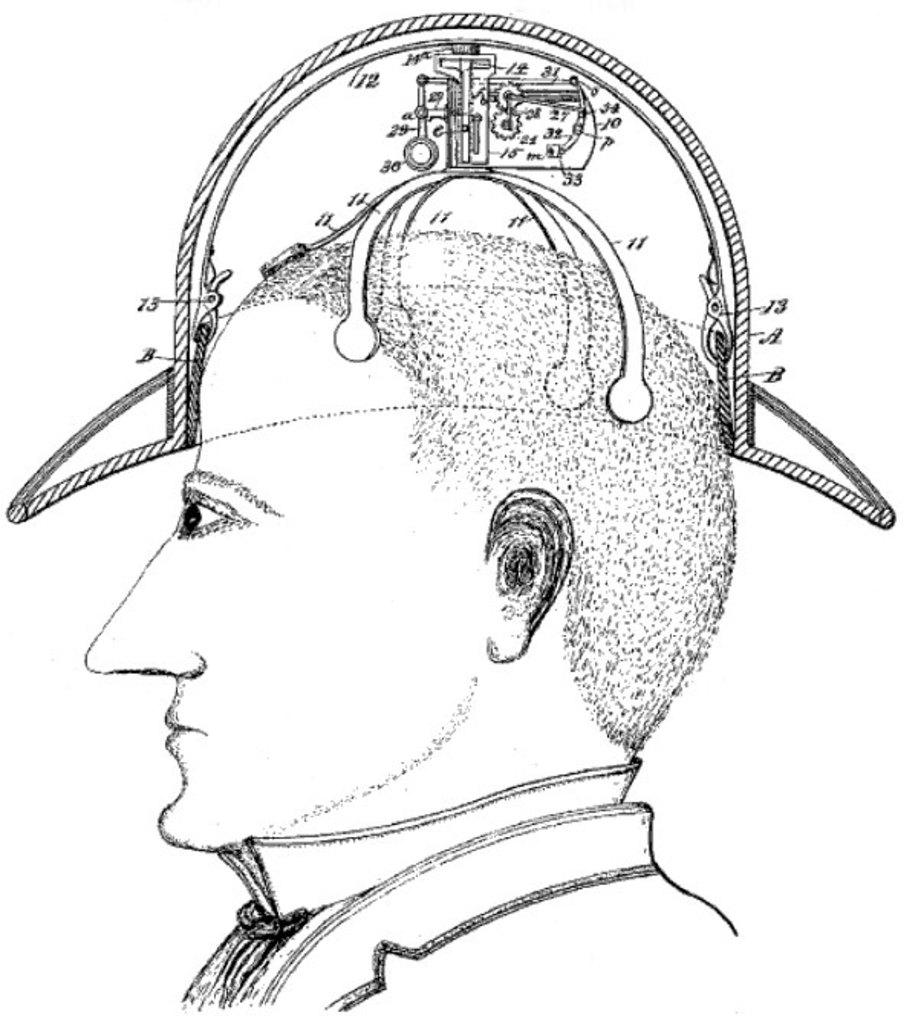What is depicted in the drawing in the image? There is a drawing of a person in the image. What else can be seen in the image besides the drawing? There are numbers and a device visible in the image. What type of plants can be seen growing in the garden in the image? There is no garden or plants present in the image; it only contains a drawing of a person, numbers, and a device. 